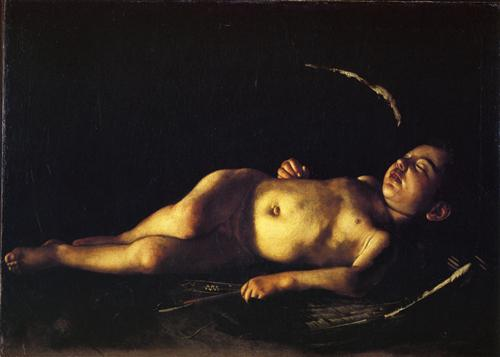Imagine the boy in the painting wakes up. What might he do next? If the boy in the painting were to wake up, he might slowly stretch and blink his eyes, adjusting to the light around him. He could then sit up on the wooden bench, perhaps taking in his surroundings with a look of curiosity and wonder. Given the serene environment, he might feel a sense of calm and contentment, possibly inspired to explore the area or engage in a quiet activity like reading or drawing. This imagined next moment continues the theme of tranquility and innocence that permeates the artwork. What time of day do you think it is in the painting, and why? The time of day in the painting is somewhat ambiguous, but the soft, gentle lighting could suggest either early morning or late afternoon. These times are often associated with a warm, diffused light that casts a serene and peaceful glow. The artist's use of light to emphasize the boy's repose could indicate a moment of rest either at the start or the close of the day, both of which can evoke a natural sense of tranquility and reflection. 